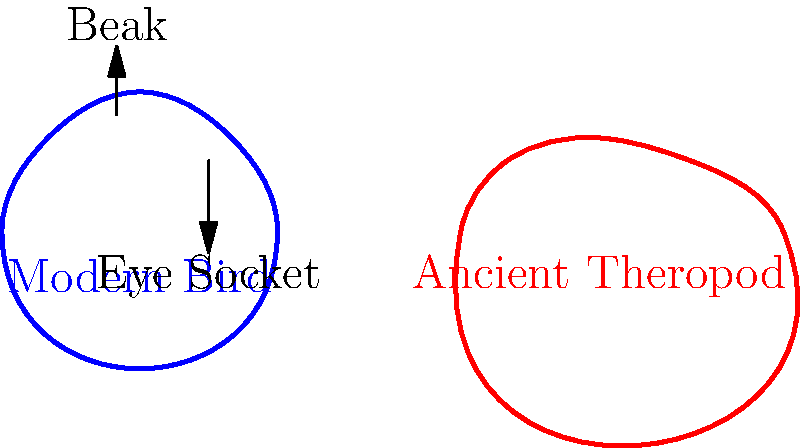Compare the skull structures of the modern bird and the ancient theropod dinosaur shown in the diagram. Which anatomical feature shows the most significant difference between these two related groups, and how does this difference relate to their respective ecological niches? To answer this question, we need to analyze the key anatomical features of both skulls:

1. Beak structure:
   - Modern bird: Elongated, pointed beak without teeth
   - Ancient theropod: Shorter snout with visible teeth sockets

2. Eye socket:
   - Modern bird: Relatively larger in proportion to the skull
   - Ancient theropod: Smaller in proportion to the skull

3. Overall skull shape:
   - Modern bird: More rounded and compact
   - Ancient theropod: Elongated and robust

The most significant difference is the beak structure. This feature relates directly to their ecological niches:

1. Modern birds:
   - Toothless beak adapted for various diets (seeds, fruits, insects, fish)
   - Lightweight structure for flight efficiency
   - Specialized for different feeding strategies (e.g., probing, pecking, filtering)

2. Ancient theropods:
   - Toothed jaws adapted for carnivorous diet
   - Powerful bite force for hunting and consuming prey
   - Less specialized, suited for a broader range of prey items

The evolution of the beak in modern birds allowed for dietary diversification and adaptation to various ecological niches, while reducing skull weight for improved flight capabilities. This transformation from the toothed jaw of theropods to the diverse beak structures in birds is a key example of how anatomical changes relate to ecological adaptations over evolutionary time.
Answer: Beak structure; modern birds' toothless beaks allow dietary diversification and weight reduction for flight, while ancient theropods' toothed jaws were adapted for carnivory. 